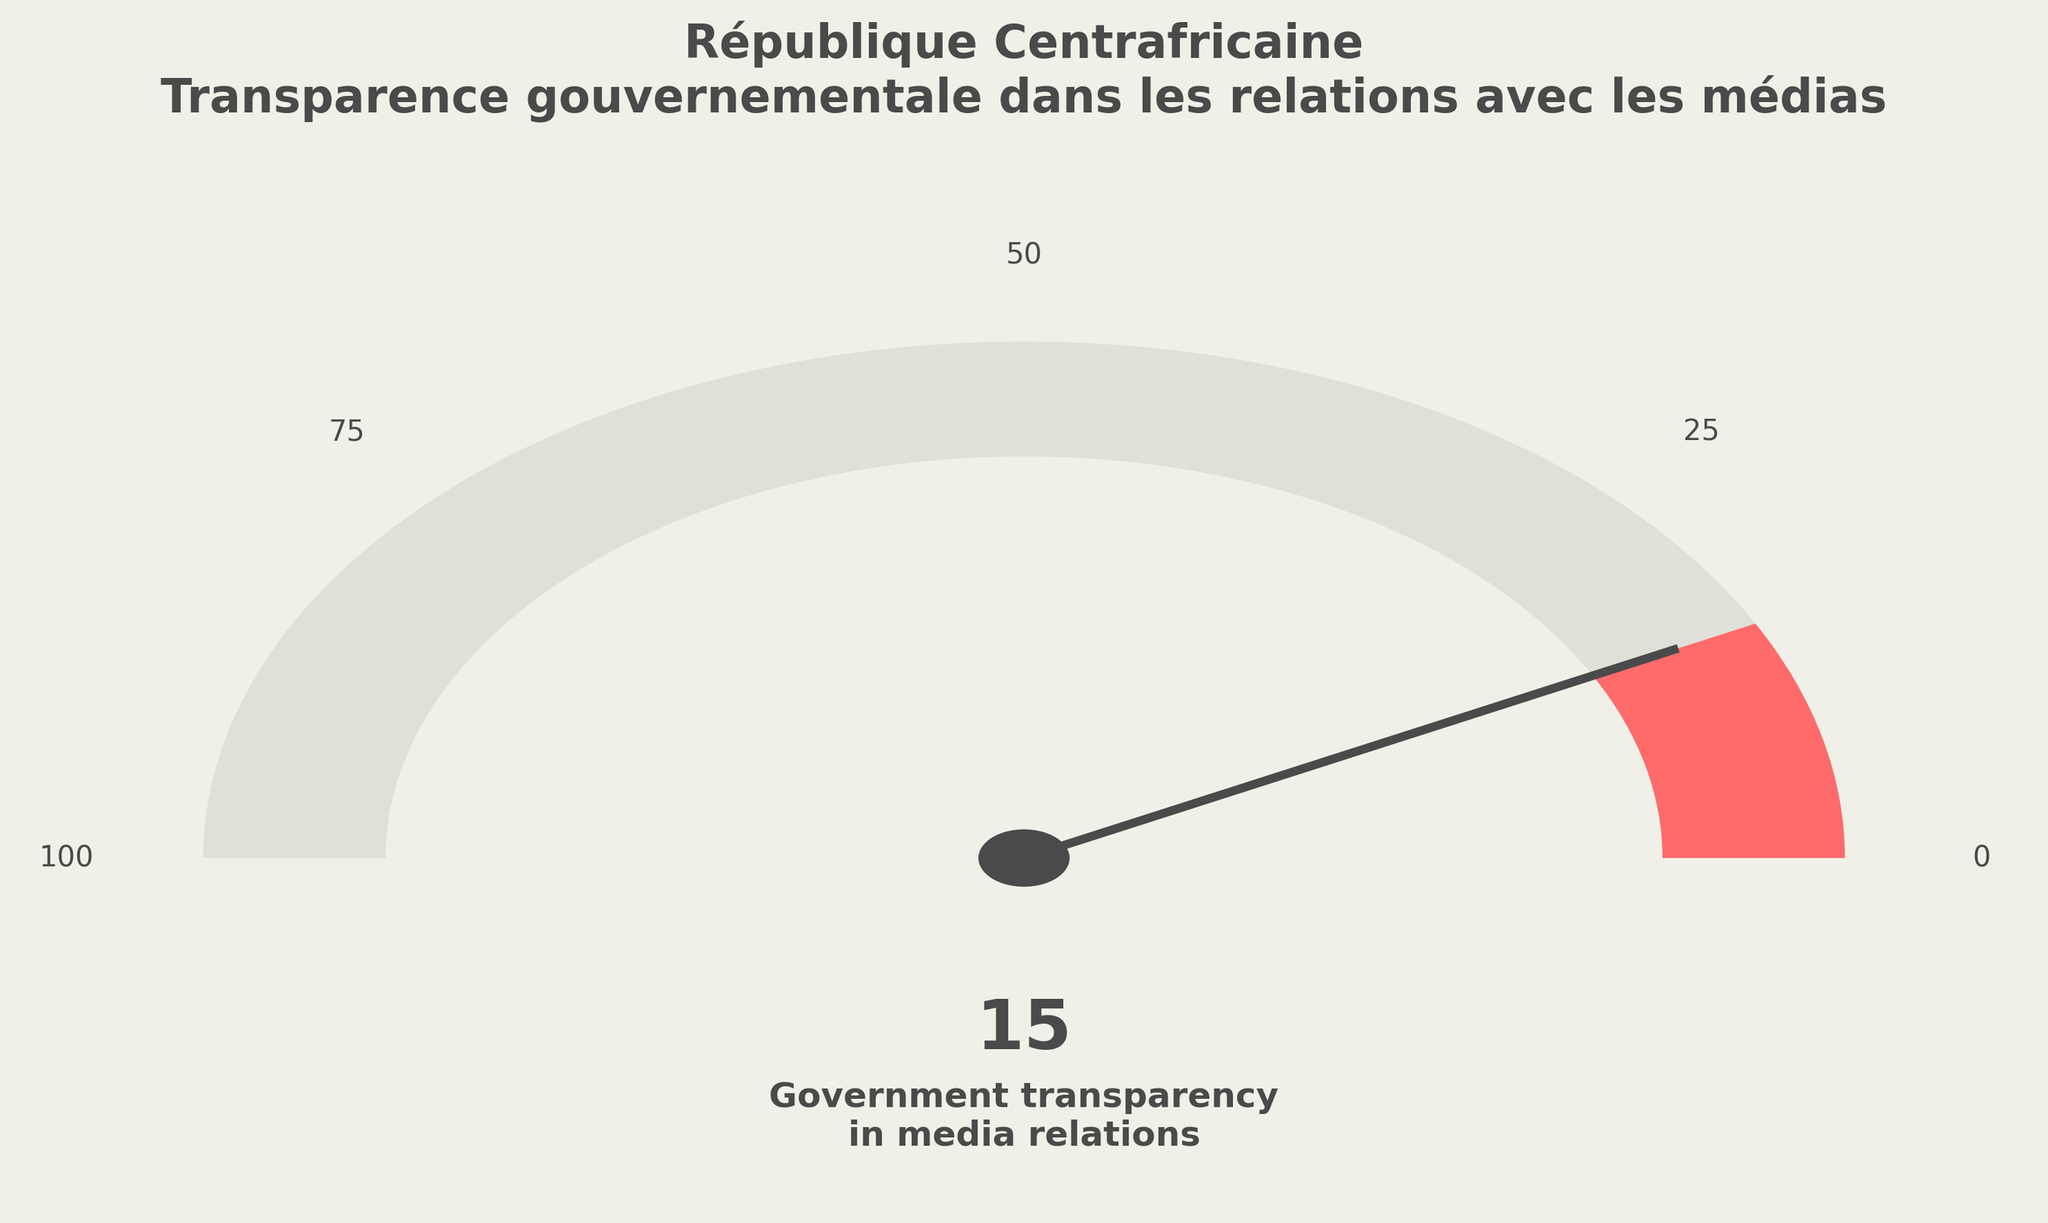What is the title of the plot? The title is located at the top of the plot, written in bold.
Answer: République Centrafricaine Transparence gouvernementale dans les relations avec les médias What is the Government transparency score in media relations? The plot shows the specific score indicated by a colored wedge and a needle on the gauge. The number is also displayed below the needle.
Answer: 15 How is the Government transparency score positioned on the gauge? The needle angle and the position of the colored wedge on the gauge indicate the score. Here, the needle points to a position relatively close to the left extremity representing 15 degrees on the gauge.
Answer: Near the beginning (15 degrees) What are the scale labels used on the gauge? The scale labels are positioned around the semi-circular gauge in equal intervals. These labels allow us to interpret the values indicated by the gauge's needle.
Answer: 0, 25, 50, 75, 100 Which category has the highest score, and what is that score? By examining the list of scores in the data provided, we can identify the highest score and match it to its corresponding category.
Answer: Press freedom index, 35 What color is used to represent 15 on the gauge? The color that corresponds to the section of the gauge where the score of 15 lies is visibly different from others. It’s essential to identify which color relates to the section closest to 15 degrees on the gauge.
Answer: One of the gauge colors (not explicitly stated) Is the Government transparency score below or above the average score of 50 displayed in the data? By comparing the Government transparency score of 15 with the average score of 50, we can establish which is higher.
Answer: Below How does the Government transparency score compare to the Access to public information score? By comparing the Government transparency score of 15 to the Access to public information score of 20, we can identify which is larger using basic arithmetic.
Answer: Lower What is the difference between the highest category score and the Government transparency score? To find the difference, we need to subtract the Government transparency score (15) from the highest score (35).
Answer: 20 Is the Government transparency score closer to the minimum or maximum score? By calculating the difference between the Government transparency score and the minimum/maximum scores, we can determine proximity. The score of 15 is closer to the minimum of 0 than to the maximum of 100.
Answer: Closer to the minimum (0) 